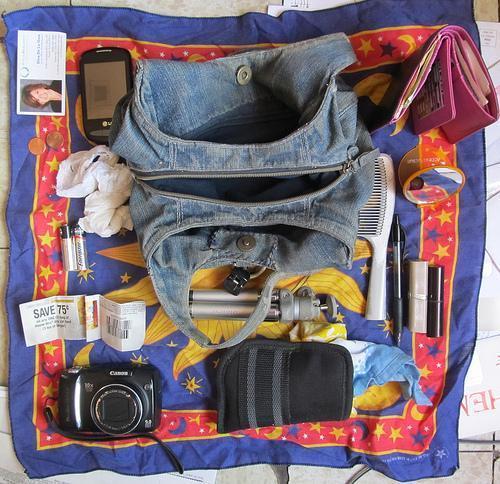How many electronics are there?
Give a very brief answer. 2. 